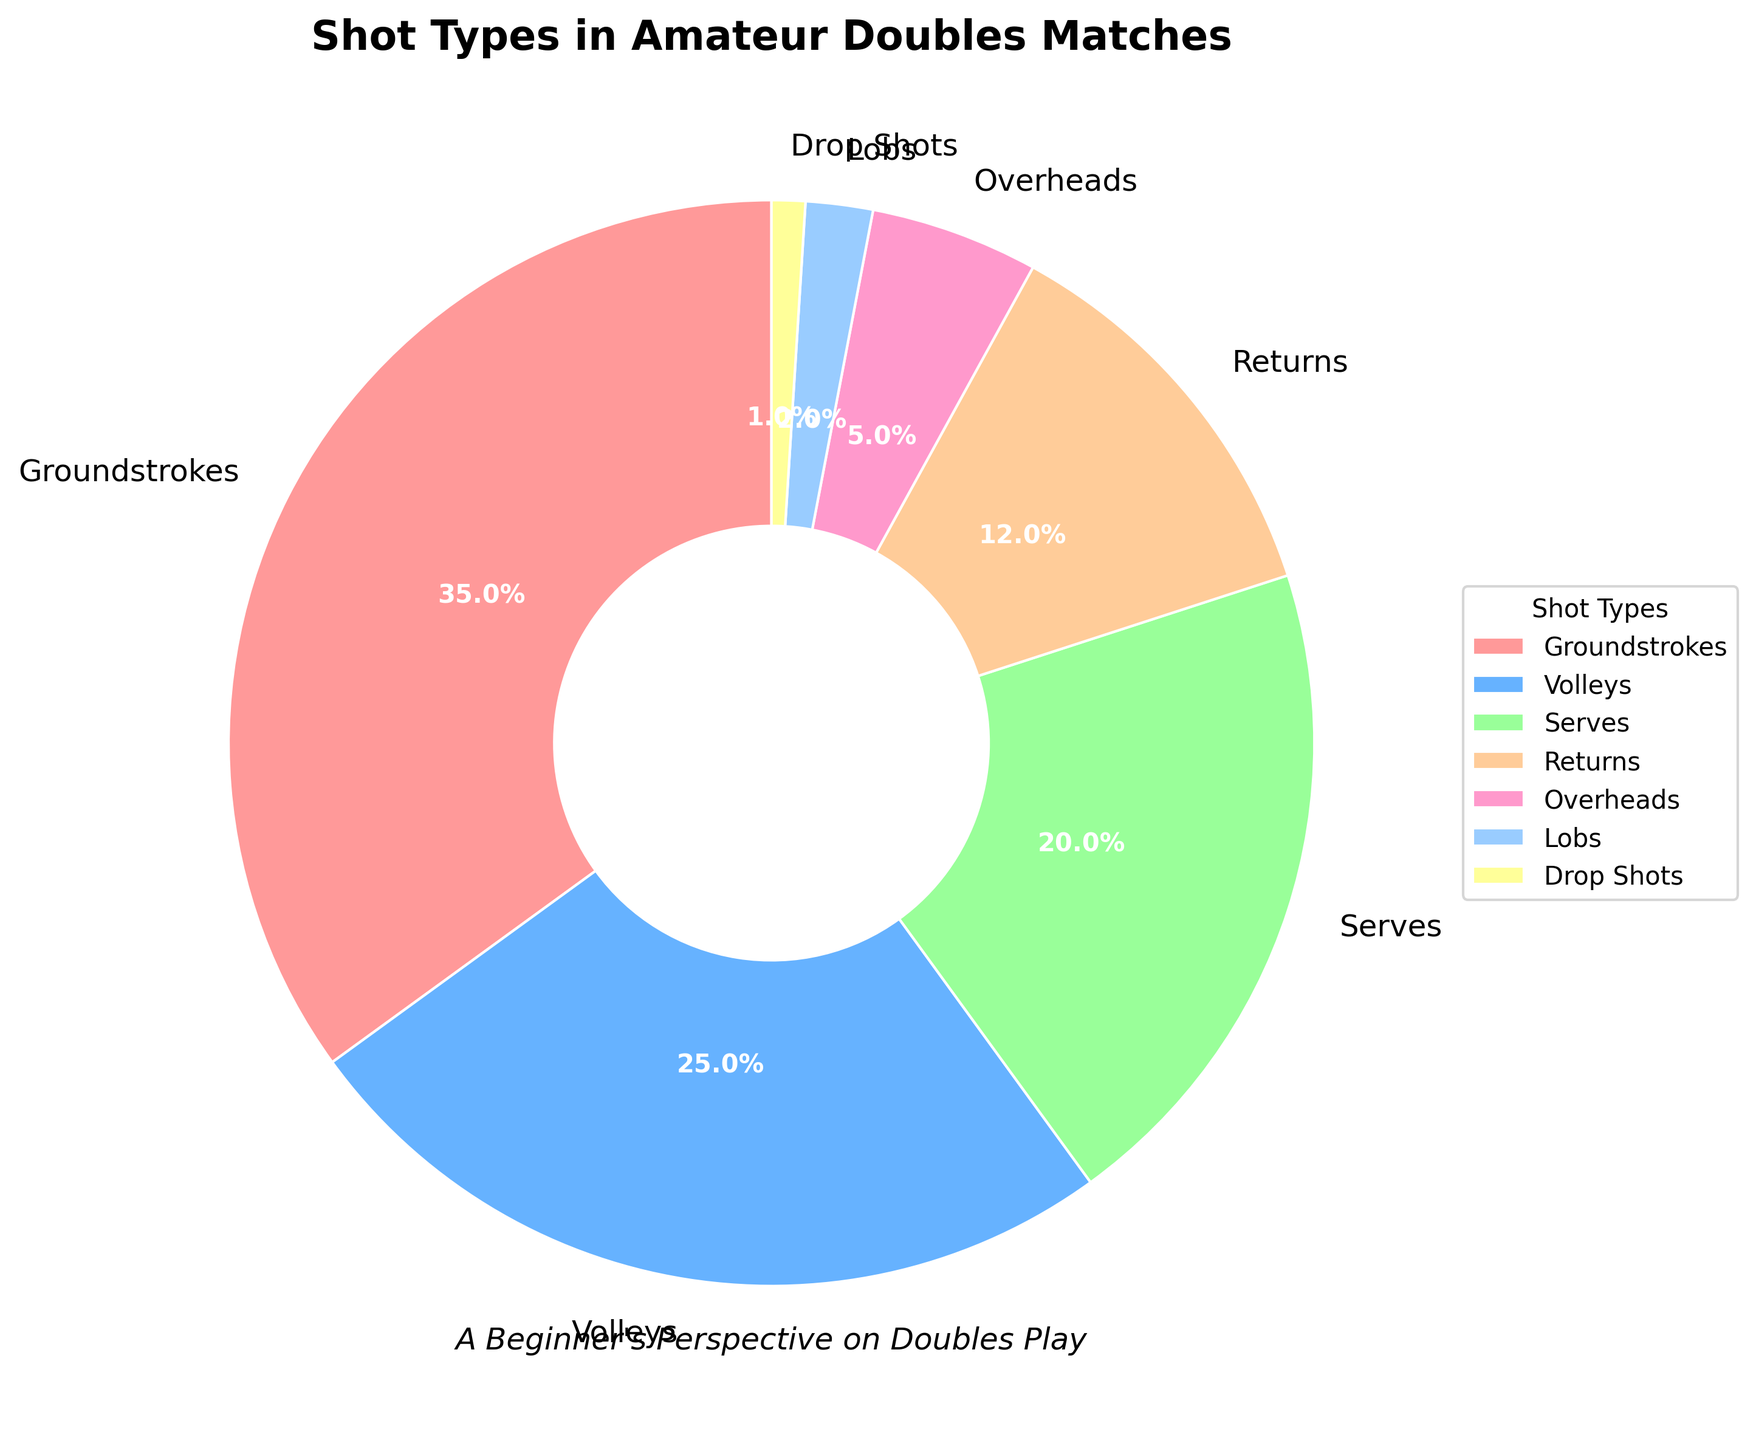What percentage of shots are volleys? The pie chart shows different shot types with their respective percentages. Look for the section labeled "Volleys" to find the associated percentage.
Answer: 25% How much more common are groundstrokes compared to serves? Find the percentages for groundstrokes and serves from the chart. Subtract the serve percentage from the groundstroke percentage: 35% - 20% = 15%.
Answer: 15% What proportion of shots are either returns or lobs? Locate the percentages for returns and lobs, then add them together: 12% (returns) + 2% (lobs) = 14%.
Answer: 14% Which shot type appears the least frequently? Identify the shot type with the smallest percentage in the pie chart. The section labeled "Drop Shots" has the lowest percentage of 1%.
Answer: Drop Shots Are serves used more frequently than returns? Compare the slices labeled "Serves" and "Returns." Serves have a percentage of 20%, while returns have 12%. Since 20% is greater than 12%, serves are used more frequently.
Answer: Yes By how much does the combined percentage of overheads and lobs exceed the drop shots percentage? Add the percentages of overheads and lobs: 5% + 2% = 7%. Subtract the percentage of drop shots from this total: 7% - 1% = 6%.
Answer: 6% Which shot type uses a section that is orange in color? Observe the different colored segments of the pie and match them with the shot type. The orange segment corresponds to "Groundstrokes."
Answer: Groundstrokes What is the difference between the percentages of the most and least frequent shot types? Determine the highest and lowest percentages: Groundstrokes (35%) and Drop Shots (1%). Subtract the smallest percentage from the largest: 35% - 1% = 34%.
Answer: 34% How does the frequency of overheads compare to that of lobs? Compare the segments for overheads and lobs. Overheads have a percentage of 5%, while lobs have 2%. Since 5% is greater than 2%, overheads are more frequent than lobs.
Answer: Overheads are more frequent If groundstrokes and volleys make up the majority of shots, what percentage of the total do they represent together? Add the percentages of groundstrokes and volleys: 35% (groundstrokes) + 25% (volleys) = 60%.
Answer: 60% 